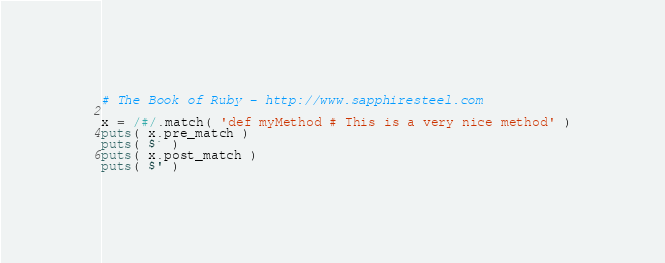Convert code to text. <code><loc_0><loc_0><loc_500><loc_500><_Ruby_># The Book of Ruby - http://www.sapphiresteel.com

x = /#/.match( 'def myMethod # This is a very nice method' )
puts( x.pre_match )
puts( $` )
puts( x.post_match )
puts( $' )
</code> 